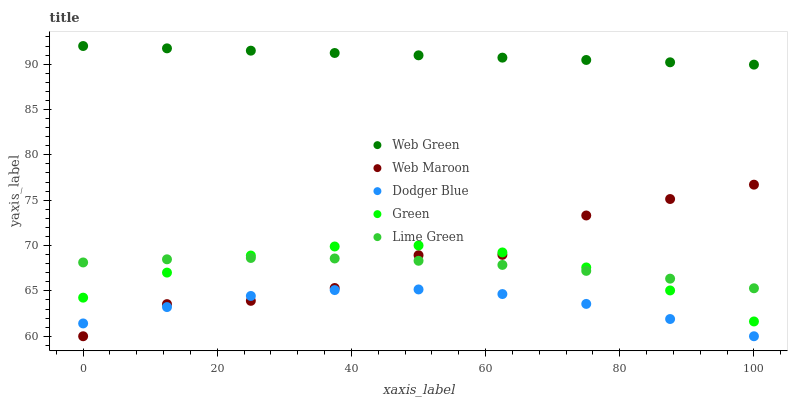Does Dodger Blue have the minimum area under the curve?
Answer yes or no. Yes. Does Web Green have the maximum area under the curve?
Answer yes or no. Yes. Does Green have the minimum area under the curve?
Answer yes or no. No. Does Green have the maximum area under the curve?
Answer yes or no. No. Is Web Green the smoothest?
Answer yes or no. Yes. Is Web Maroon the roughest?
Answer yes or no. Yes. Is Dodger Blue the smoothest?
Answer yes or no. No. Is Dodger Blue the roughest?
Answer yes or no. No. Does Dodger Blue have the lowest value?
Answer yes or no. Yes. Does Green have the lowest value?
Answer yes or no. No. Does Web Green have the highest value?
Answer yes or no. Yes. Does Green have the highest value?
Answer yes or no. No. Is Lime Green less than Web Green?
Answer yes or no. Yes. Is Web Green greater than Web Maroon?
Answer yes or no. Yes. Does Web Maroon intersect Dodger Blue?
Answer yes or no. Yes. Is Web Maroon less than Dodger Blue?
Answer yes or no. No. Is Web Maroon greater than Dodger Blue?
Answer yes or no. No. Does Lime Green intersect Web Green?
Answer yes or no. No. 